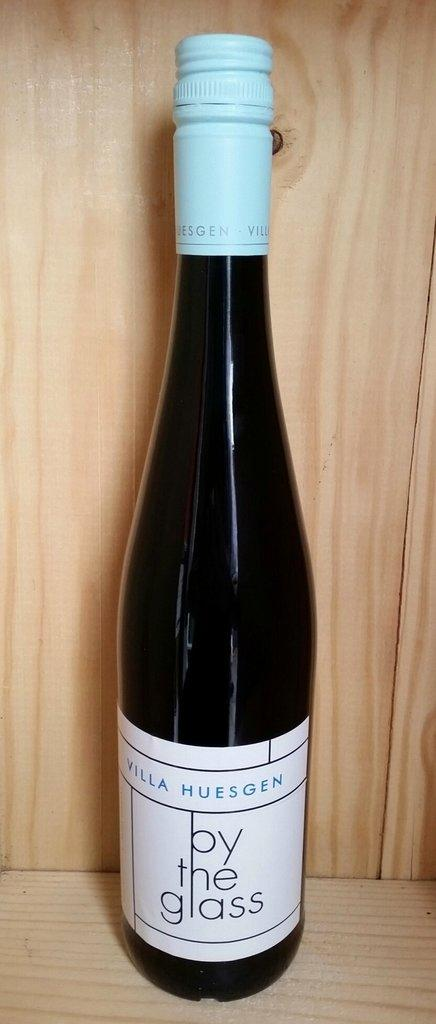<image>
Provide a brief description of the given image. A slender dark bottle of "by the glass" wine is on a display on a wooden shelf. 